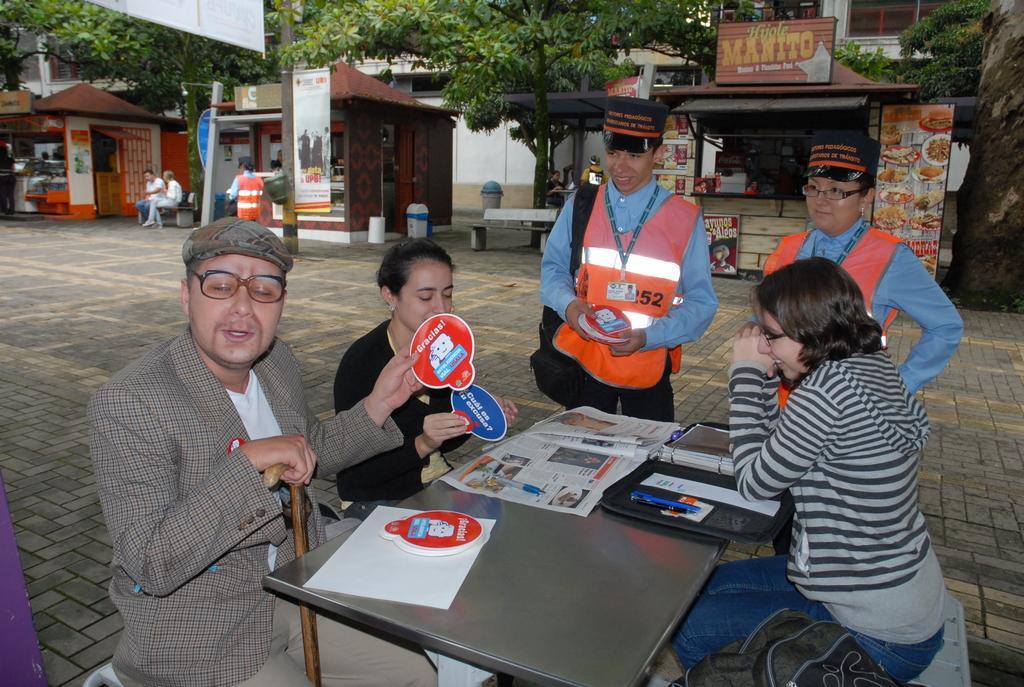Could you give a brief overview of what you see in this image? There is a man sitting on a chair and he is talking. There is a woman sitting on the right side and she is smiling. They are the two people who are looking to sell a product to this guy. In the background there is a shop , a tree. 